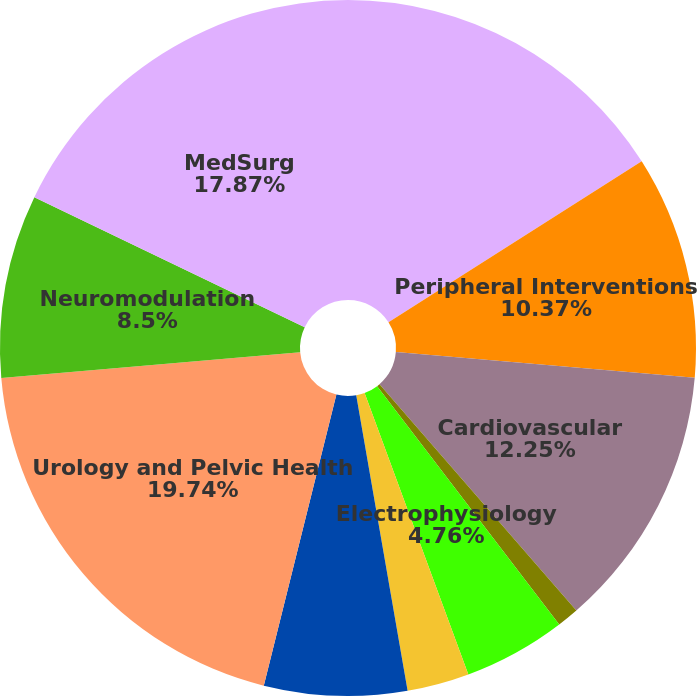Convert chart. <chart><loc_0><loc_0><loc_500><loc_500><pie_chart><fcel>Interventional Cardiology<fcel>Peripheral Interventions<fcel>Cardiovascular<fcel>Cardiac Rhythm Management<fcel>Electrophysiology<fcel>Rhythm Management<fcel>Endoscopy<fcel>Urology and Pelvic Health<fcel>Neuromodulation<fcel>MedSurg<nl><fcel>15.99%<fcel>10.37%<fcel>12.25%<fcel>1.01%<fcel>4.76%<fcel>2.88%<fcel>6.63%<fcel>19.74%<fcel>8.5%<fcel>17.87%<nl></chart> 